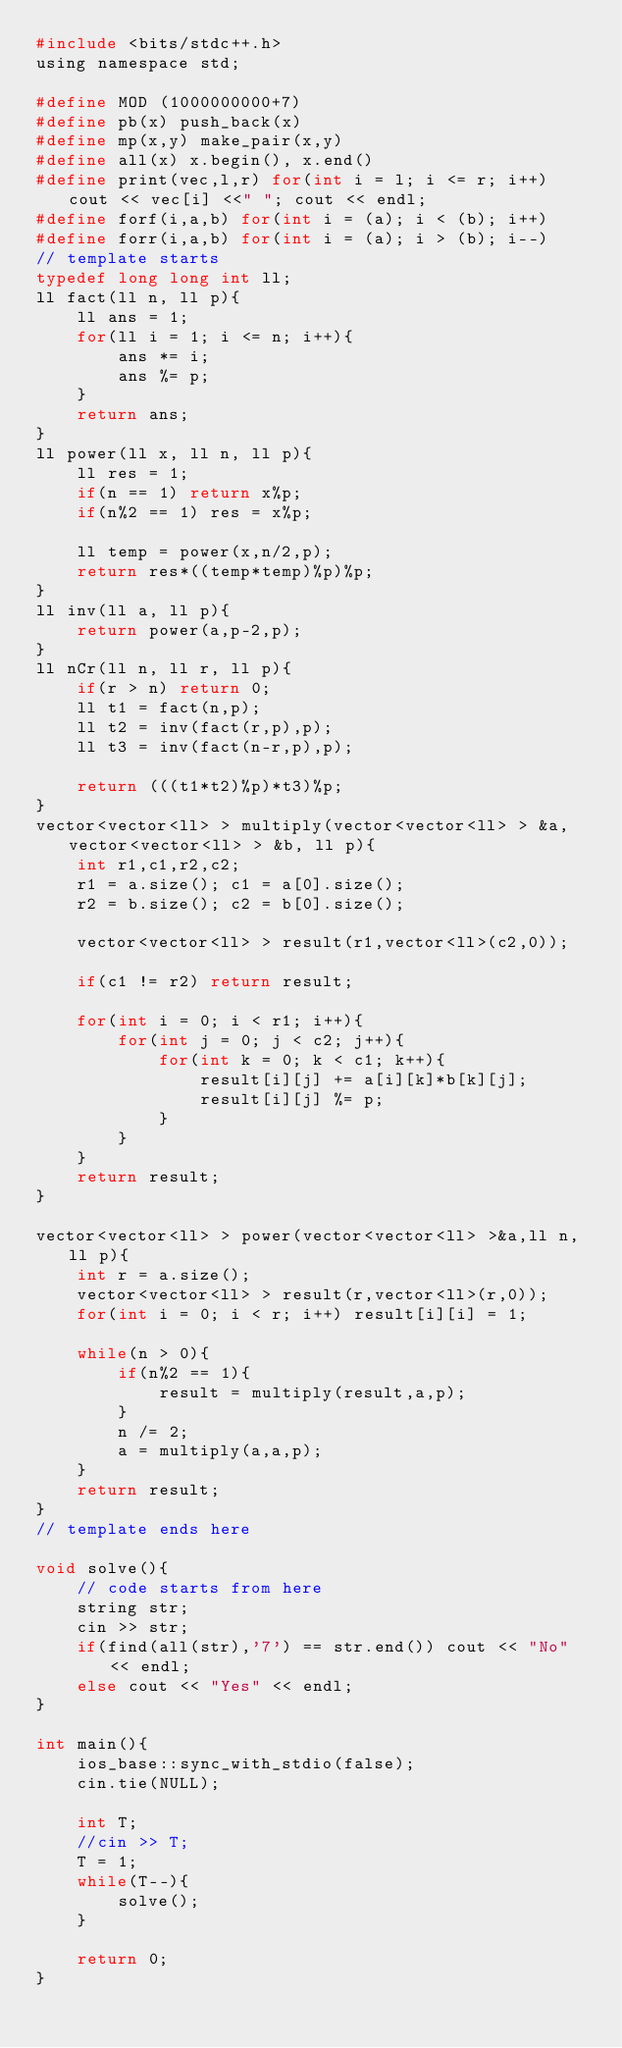<code> <loc_0><loc_0><loc_500><loc_500><_C_>#include <bits/stdc++.h>
using namespace std;

#define MOD (1000000000+7)
#define pb(x) push_back(x)
#define mp(x,y) make_pair(x,y)
#define all(x) x.begin(), x.end()
#define print(vec,l,r) for(int i = l; i <= r; i++) cout << vec[i] <<" "; cout << endl;
#define forf(i,a,b) for(int i = (a); i < (b); i++)
#define forr(i,a,b) for(int i = (a); i > (b); i--)
// template starts
typedef long long int ll;
ll fact(ll n, ll p){
	ll ans = 1;
	for(ll i = 1; i <= n; i++){
		ans *= i;
		ans %= p;
	}
	return ans;
}
ll power(ll x, ll n, ll p){
	ll res = 1;
	if(n == 1) return x%p;
	if(n%2 == 1) res = x%p;

	ll temp = power(x,n/2,p);
	return res*((temp*temp)%p)%p;
}
ll inv(ll a, ll p){
	return power(a,p-2,p);
}
ll nCr(ll n, ll r, ll p){
	if(r > n) return 0;
	ll t1 = fact(n,p);
	ll t2 = inv(fact(r,p),p);
	ll t3 = inv(fact(n-r,p),p);

	return (((t1*t2)%p)*t3)%p;
}
vector<vector<ll> > multiply(vector<vector<ll> > &a, vector<vector<ll> > &b, ll p){
	int r1,c1,r2,c2;
	r1 = a.size(); c1 = a[0].size();
	r2 = b.size(); c2 = b[0].size();

	vector<vector<ll> > result(r1,vector<ll>(c2,0));

	if(c1 != r2) return result;

	for(int i = 0; i < r1; i++){
		for(int j = 0; j < c2; j++){
			for(int k = 0; k < c1; k++){
				result[i][j] += a[i][k]*b[k][j];
				result[i][j] %= p;
			}
		}
	}
	return result;
}

vector<vector<ll> > power(vector<vector<ll> >&a,ll n, ll p){
	int r = a.size();
	vector<vector<ll> > result(r,vector<ll>(r,0));
	for(int i = 0; i < r; i++) result[i][i] = 1;

	while(n > 0){
		if(n%2 == 1){
			result = multiply(result,a,p);
		}
		n /= 2;
		a = multiply(a,a,p);
	}
	return result;
}
// template ends here

void solve(){
	// code starts from here
	string str;
	cin >> str;
	if(find(all(str),'7') == str.end()) cout << "No" << endl;
	else cout << "Yes" << endl;
}

int main(){
 	ios_base::sync_with_stdio(false);
    cin.tie(NULL);

	int T;
	//cin >> T;
	T = 1;
	while(T--){
		solve();
	}

	return 0;
}
</code> 